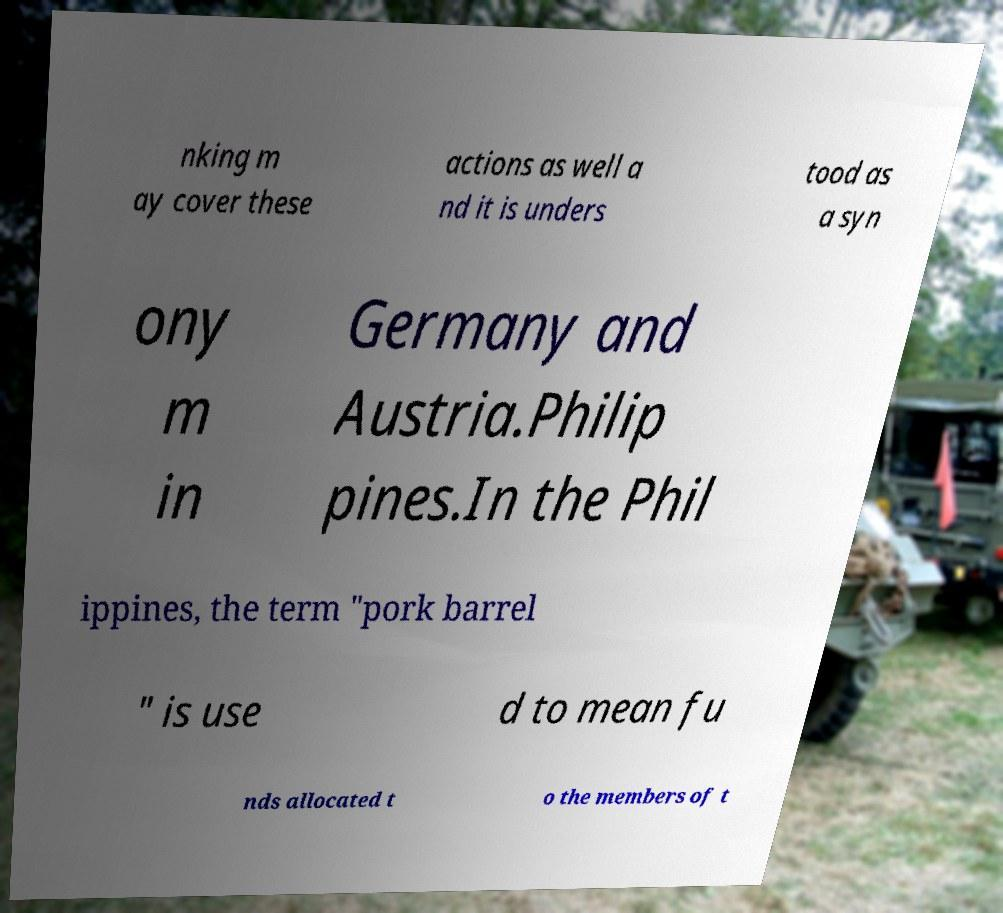Can you read and provide the text displayed in the image?This photo seems to have some interesting text. Can you extract and type it out for me? nking m ay cover these actions as well a nd it is unders tood as a syn ony m in Germany and Austria.Philip pines.In the Phil ippines, the term "pork barrel " is use d to mean fu nds allocated t o the members of t 